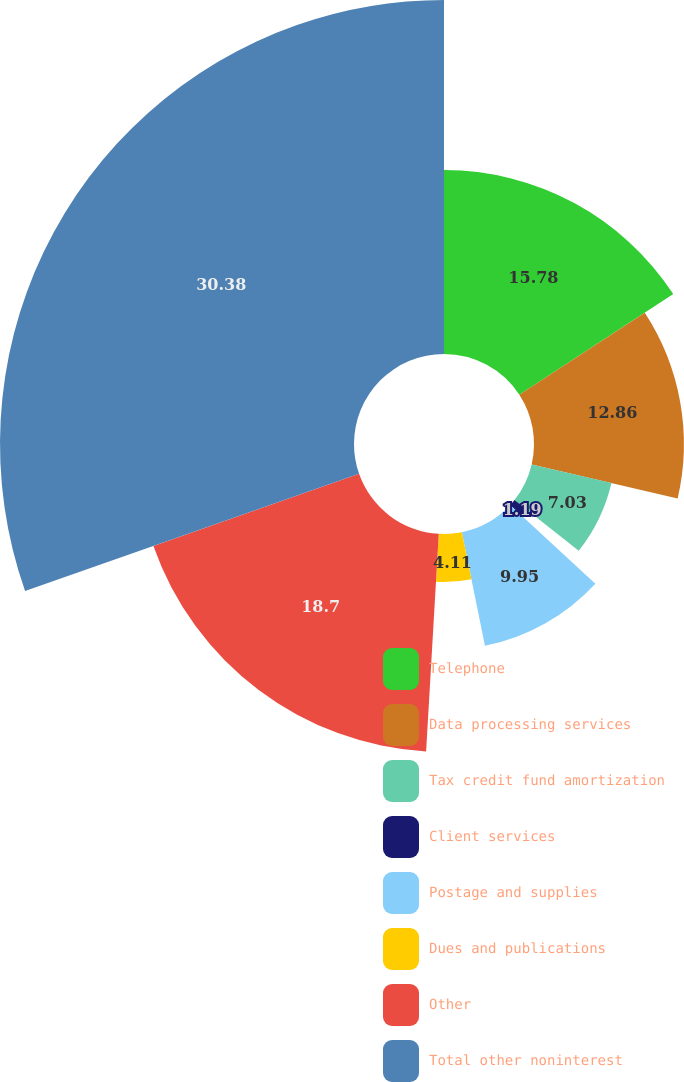Convert chart. <chart><loc_0><loc_0><loc_500><loc_500><pie_chart><fcel>Telephone<fcel>Data processing services<fcel>Tax credit fund amortization<fcel>Client services<fcel>Postage and supplies<fcel>Dues and publications<fcel>Other<fcel>Total other noninterest<nl><fcel>15.78%<fcel>12.86%<fcel>7.03%<fcel>1.19%<fcel>9.95%<fcel>4.11%<fcel>18.7%<fcel>30.37%<nl></chart> 